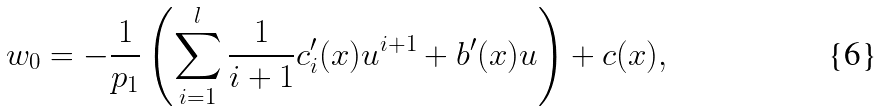<formula> <loc_0><loc_0><loc_500><loc_500>w _ { 0 } = - \frac { 1 } { p _ { 1 } } \left ( \sum _ { i = 1 } ^ { l } \frac { 1 } { i + 1 } c ^ { \prime } _ { i } ( x ) u ^ { i + 1 } + b ^ { \prime } ( x ) u \right ) + c ( x ) ,</formula> 